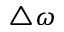<formula> <loc_0><loc_0><loc_500><loc_500>\triangle \omega</formula> 